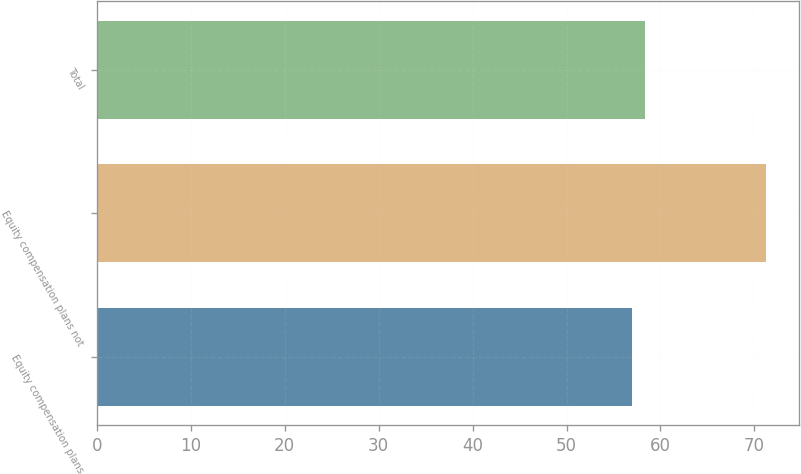<chart> <loc_0><loc_0><loc_500><loc_500><bar_chart><fcel>Equity compensation plans<fcel>Equity compensation plans not<fcel>Total<nl><fcel>56.93<fcel>71.22<fcel>58.36<nl></chart> 